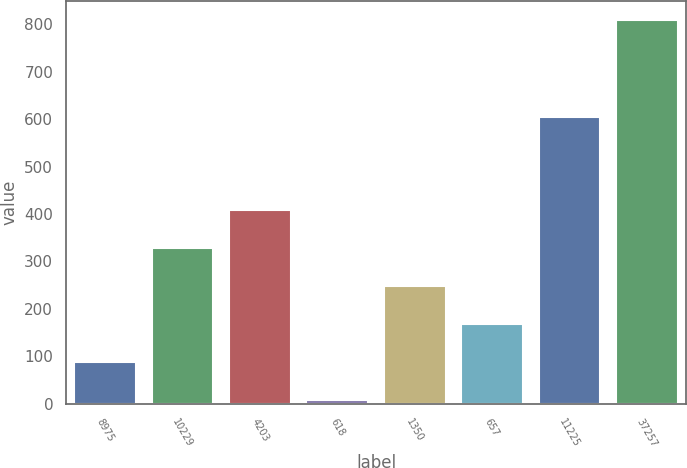<chart> <loc_0><loc_0><loc_500><loc_500><bar_chart><fcel>8975<fcel>10229<fcel>4203<fcel>618<fcel>1350<fcel>657<fcel>11225<fcel>37257<nl><fcel>88.89<fcel>328.86<fcel>408.85<fcel>8.9<fcel>248.87<fcel>168.88<fcel>604.2<fcel>808.8<nl></chart> 